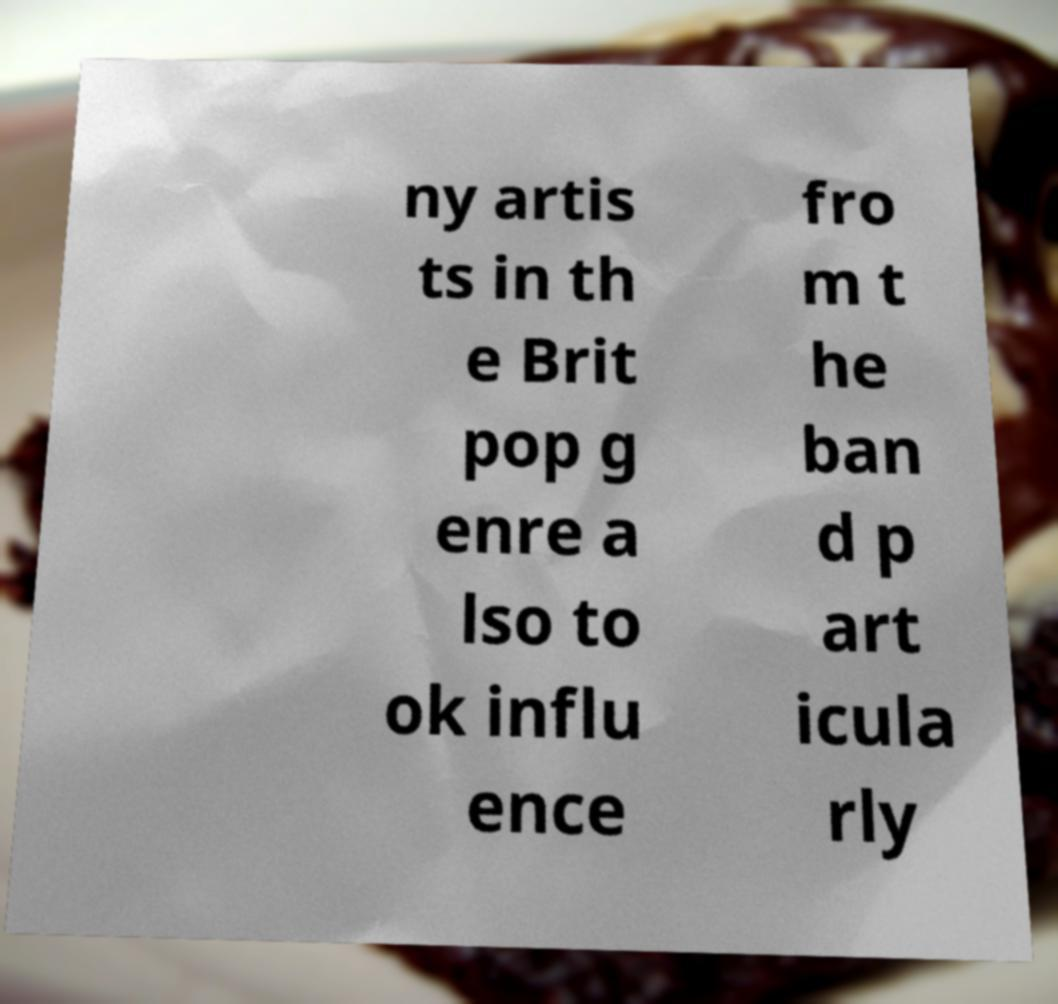I need the written content from this picture converted into text. Can you do that? ny artis ts in th e Brit pop g enre a lso to ok influ ence fro m t he ban d p art icula rly 